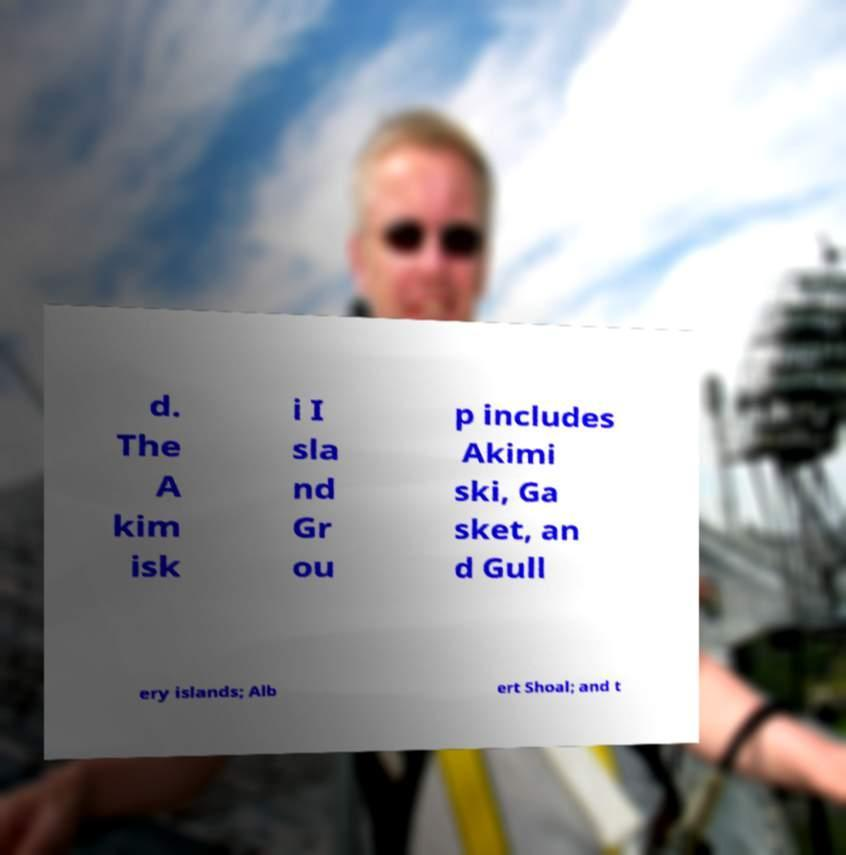I need the written content from this picture converted into text. Can you do that? d. The A kim isk i I sla nd Gr ou p includes Akimi ski, Ga sket, an d Gull ery islands; Alb ert Shoal; and t 